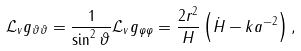Convert formula to latex. <formula><loc_0><loc_0><loc_500><loc_500>\mathcal { L } _ { v } g _ { \vartheta \vartheta } = \frac { 1 } { \sin ^ { 2 } \vartheta } \mathcal { L } _ { v } g _ { \varphi \varphi } = \frac { 2 r ^ { 2 } } { H } \left ( \dot { H } - k a ^ { - 2 } \right ) ,</formula> 